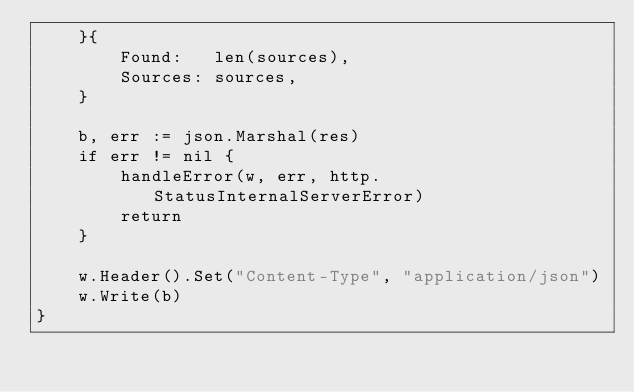Convert code to text. <code><loc_0><loc_0><loc_500><loc_500><_Go_>	}{
		Found:   len(sources),
		Sources: sources,
	}

	b, err := json.Marshal(res)
	if err != nil {
		handleError(w, err, http.StatusInternalServerError)
		return
	}

	w.Header().Set("Content-Type", "application/json")
	w.Write(b)
}
</code> 